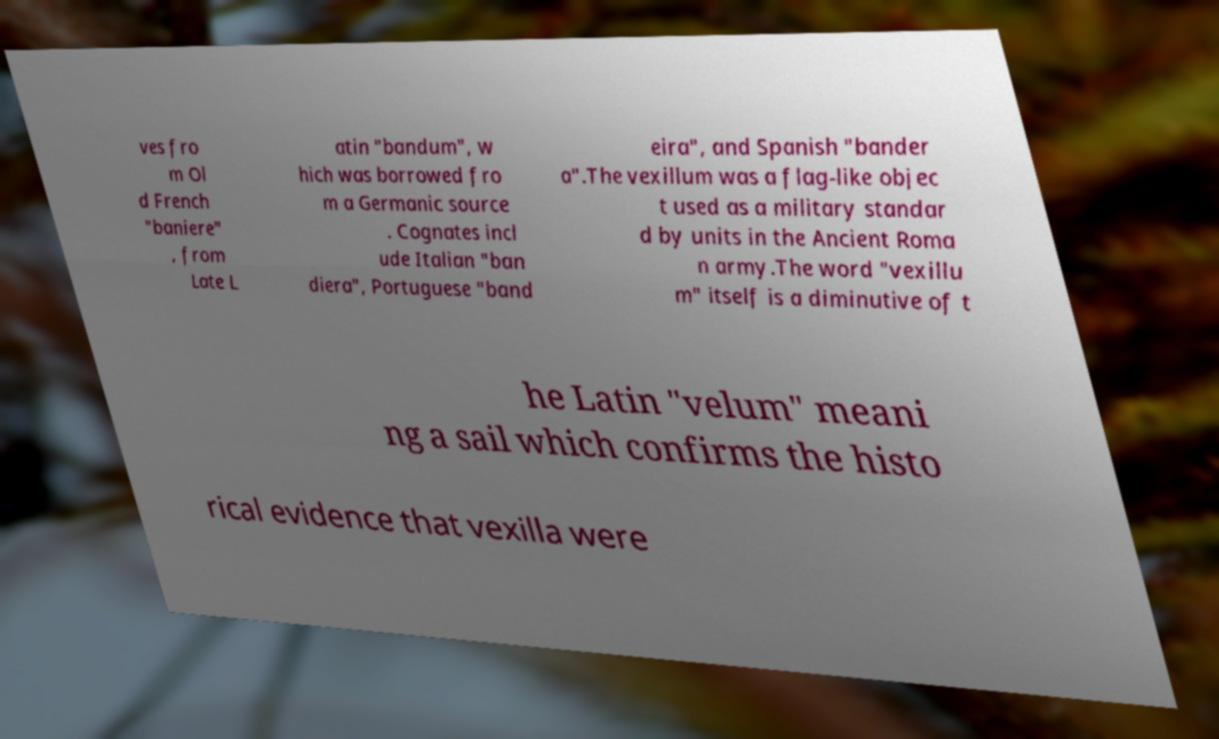What messages or text are displayed in this image? I need them in a readable, typed format. ves fro m Ol d French "baniere" , from Late L atin "bandum", w hich was borrowed fro m a Germanic source . Cognates incl ude Italian "ban diera", Portuguese "band eira", and Spanish "bander a".The vexillum was a flag-like objec t used as a military standar d by units in the Ancient Roma n army.The word "vexillu m" itself is a diminutive of t he Latin "velum" meani ng a sail which confirms the histo rical evidence that vexilla were 